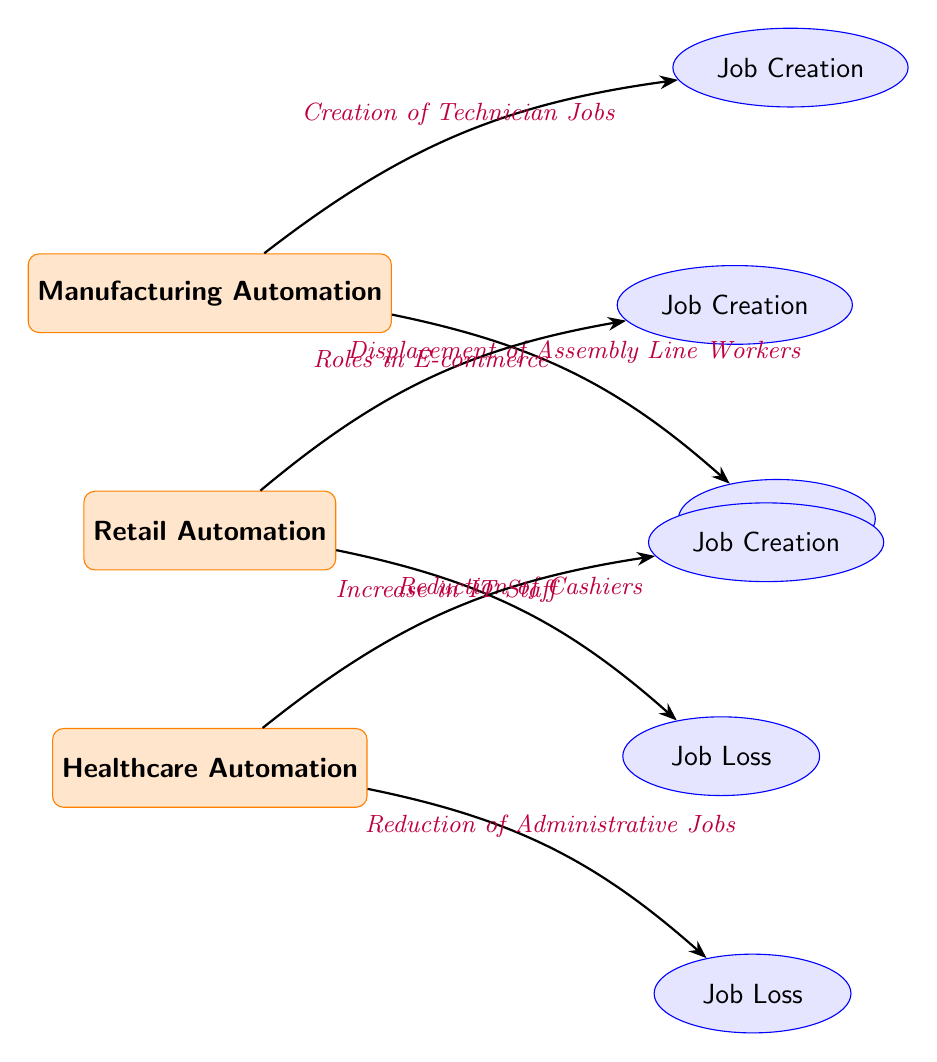What automation type is listed at the top of the diagram? The diagram displays three types of automation, and the top one is referred to as Manufacturing Automation.
Answer: Manufacturing Automation How many job creation nodes are present in the diagram? There are three job creation nodes in the diagram, each corresponding to the three types of automation.
Answer: 3 What job loss is associated with healthcare automation? The diagram indicates that healthcare automation leads to the Reduction of Administrative Jobs.
Answer: Reduction of Administrative Jobs Which job creation is linked to retail automation? The link between retail automation and job creation is identified as Roles in E-commerce.
Answer: Roles in E-commerce What is the relationship between Manufacturing Automation and job loss? Manufacturing Automation is connected to job loss through the Displacement of Assembly Line Workers.
Answer: Displacement of Assembly Line Workers How does healthcare automation affect job creation? The diagram shows that healthcare automation leads to an Increase in IT Staff as a form of job creation.
Answer: Increase in IT Staff Which automation type has the highest potential for job loss according to the diagram? The diagram indicates that healthcare automation has a significant impact on job loss through the Reduction of Administrative Jobs, along with retail automation.
Answer: Reduction of Administrative Jobs What are the two transitions from retail automation? The diagram shows two transitions: one leads to Job Creation through Roles in E-commerce, and the other leads to Job Loss through Reduction of Cashiers.
Answer: Roles in E-commerce and Reduction of Cashiers Why might Manufacturing Automation be seen as a double-edged sword? This type of automation is depicted with both Job Creation through the Creation of Technician Jobs and Job Loss through the Displacement of Assembly Line Workers, highlighting its dual impact.
Answer: Creation of Technician Jobs and Displacement of Assembly Line Workers 